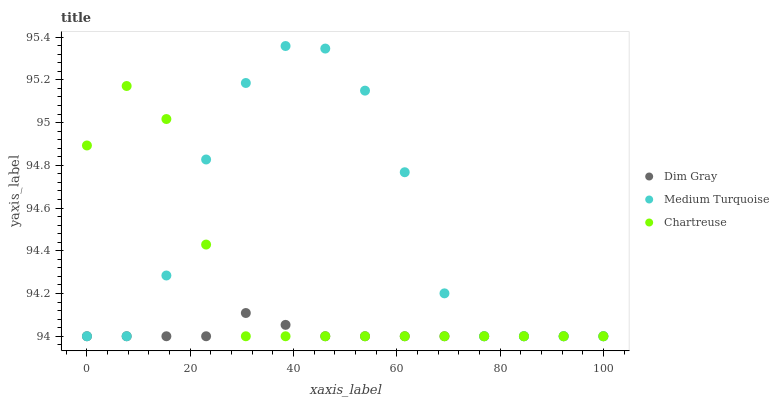Does Dim Gray have the minimum area under the curve?
Answer yes or no. Yes. Does Medium Turquoise have the maximum area under the curve?
Answer yes or no. Yes. Does Medium Turquoise have the minimum area under the curve?
Answer yes or no. No. Does Dim Gray have the maximum area under the curve?
Answer yes or no. No. Is Dim Gray the smoothest?
Answer yes or no. Yes. Is Medium Turquoise the roughest?
Answer yes or no. Yes. Is Medium Turquoise the smoothest?
Answer yes or no. No. Is Dim Gray the roughest?
Answer yes or no. No. Does Chartreuse have the lowest value?
Answer yes or no. Yes. Does Medium Turquoise have the highest value?
Answer yes or no. Yes. Does Dim Gray have the highest value?
Answer yes or no. No. Does Dim Gray intersect Chartreuse?
Answer yes or no. Yes. Is Dim Gray less than Chartreuse?
Answer yes or no. No. Is Dim Gray greater than Chartreuse?
Answer yes or no. No. 